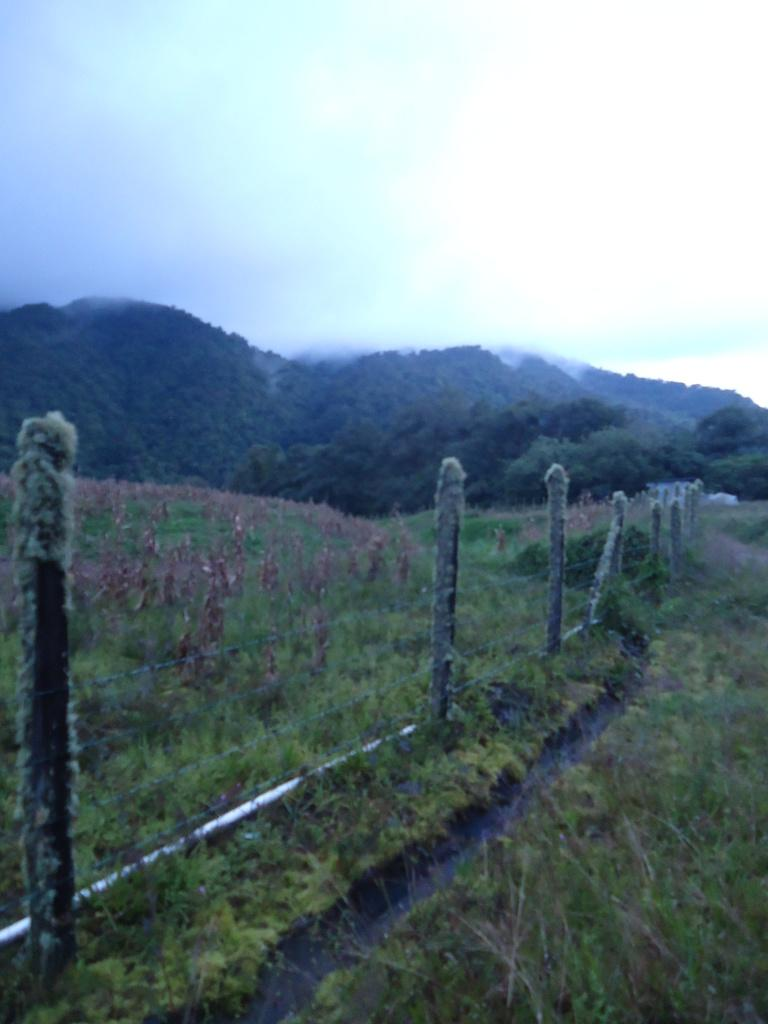What type of structure can be seen in the image? There is fencing in the image. What type of natural elements are present in the image? There are trees, grass, plants, and hills in the image. What is visible in the sky in the image? The sky is visible in the image, and clouds are present. What type of locket can be seen hanging from the tree in the image? There is no locket present in the image; it only features trees, grass, plants, hills, fencing, and a sky with clouds. How many grapes are visible on the hill in the image? There are no grapes visible in the image; it only features trees, grass, plants, hills, fencing, and a sky with clouds. 